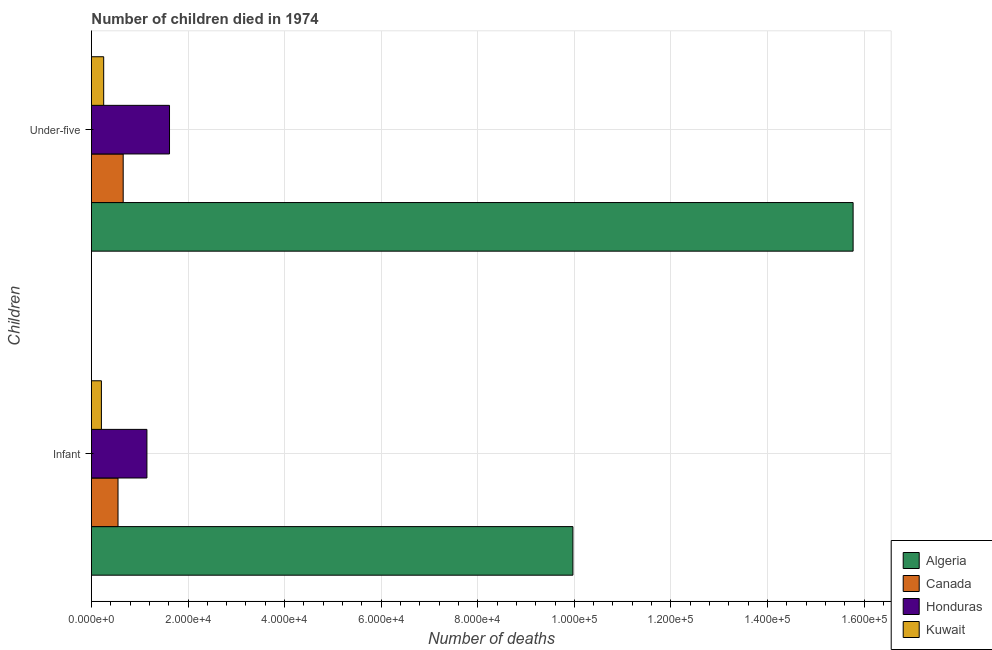How many groups of bars are there?
Offer a terse response. 2. Are the number of bars per tick equal to the number of legend labels?
Keep it short and to the point. Yes. Are the number of bars on each tick of the Y-axis equal?
Provide a succinct answer. Yes. How many bars are there on the 2nd tick from the top?
Keep it short and to the point. 4. How many bars are there on the 2nd tick from the bottom?
Offer a terse response. 4. What is the label of the 1st group of bars from the top?
Keep it short and to the point. Under-five. What is the number of under-five deaths in Algeria?
Give a very brief answer. 1.58e+05. Across all countries, what is the maximum number of under-five deaths?
Your response must be concise. 1.58e+05. Across all countries, what is the minimum number of under-five deaths?
Provide a short and direct response. 2539. In which country was the number of under-five deaths maximum?
Give a very brief answer. Algeria. In which country was the number of under-five deaths minimum?
Make the answer very short. Kuwait. What is the total number of under-five deaths in the graph?
Provide a short and direct response. 1.83e+05. What is the difference between the number of under-five deaths in Kuwait and that in Canada?
Keep it short and to the point. -4038. What is the difference between the number of under-five deaths in Honduras and the number of infant deaths in Canada?
Provide a succinct answer. 1.07e+04. What is the average number of infant deaths per country?
Keep it short and to the point. 2.97e+04. What is the difference between the number of under-five deaths and number of infant deaths in Algeria?
Provide a succinct answer. 5.80e+04. What is the ratio of the number of under-five deaths in Canada to that in Algeria?
Provide a succinct answer. 0.04. Is the number of under-five deaths in Kuwait less than that in Canada?
Offer a terse response. Yes. In how many countries, is the number of under-five deaths greater than the average number of under-five deaths taken over all countries?
Ensure brevity in your answer.  1. What does the 3rd bar from the top in Under-five represents?
Your answer should be very brief. Canada. What does the 1st bar from the bottom in Infant represents?
Make the answer very short. Algeria. Are all the bars in the graph horizontal?
Ensure brevity in your answer.  Yes. What is the difference between two consecutive major ticks on the X-axis?
Ensure brevity in your answer.  2.00e+04. Are the values on the major ticks of X-axis written in scientific E-notation?
Offer a very short reply. Yes. How many legend labels are there?
Offer a very short reply. 4. How are the legend labels stacked?
Ensure brevity in your answer.  Vertical. What is the title of the graph?
Provide a short and direct response. Number of children died in 1974. What is the label or title of the X-axis?
Offer a very short reply. Number of deaths. What is the label or title of the Y-axis?
Provide a short and direct response. Children. What is the Number of deaths of Algeria in Infant?
Your response must be concise. 9.97e+04. What is the Number of deaths in Canada in Infant?
Your response must be concise. 5505. What is the Number of deaths in Honduras in Infant?
Keep it short and to the point. 1.15e+04. What is the Number of deaths of Kuwait in Infant?
Your answer should be very brief. 2066. What is the Number of deaths of Algeria in Under-five?
Your answer should be compact. 1.58e+05. What is the Number of deaths in Canada in Under-five?
Offer a terse response. 6577. What is the Number of deaths in Honduras in Under-five?
Provide a short and direct response. 1.62e+04. What is the Number of deaths of Kuwait in Under-five?
Ensure brevity in your answer.  2539. Across all Children, what is the maximum Number of deaths of Algeria?
Your answer should be compact. 1.58e+05. Across all Children, what is the maximum Number of deaths of Canada?
Offer a terse response. 6577. Across all Children, what is the maximum Number of deaths in Honduras?
Ensure brevity in your answer.  1.62e+04. Across all Children, what is the maximum Number of deaths of Kuwait?
Your answer should be very brief. 2539. Across all Children, what is the minimum Number of deaths of Algeria?
Your answer should be very brief. 9.97e+04. Across all Children, what is the minimum Number of deaths of Canada?
Your answer should be very brief. 5505. Across all Children, what is the minimum Number of deaths of Honduras?
Keep it short and to the point. 1.15e+04. Across all Children, what is the minimum Number of deaths in Kuwait?
Provide a succinct answer. 2066. What is the total Number of deaths in Algeria in the graph?
Your response must be concise. 2.57e+05. What is the total Number of deaths in Canada in the graph?
Your answer should be very brief. 1.21e+04. What is the total Number of deaths of Honduras in the graph?
Offer a very short reply. 2.77e+04. What is the total Number of deaths of Kuwait in the graph?
Give a very brief answer. 4605. What is the difference between the Number of deaths of Algeria in Infant and that in Under-five?
Your response must be concise. -5.80e+04. What is the difference between the Number of deaths in Canada in Infant and that in Under-five?
Ensure brevity in your answer.  -1072. What is the difference between the Number of deaths in Honduras in Infant and that in Under-five?
Offer a very short reply. -4680. What is the difference between the Number of deaths in Kuwait in Infant and that in Under-five?
Make the answer very short. -473. What is the difference between the Number of deaths of Algeria in Infant and the Number of deaths of Canada in Under-five?
Your response must be concise. 9.31e+04. What is the difference between the Number of deaths of Algeria in Infant and the Number of deaths of Honduras in Under-five?
Give a very brief answer. 8.35e+04. What is the difference between the Number of deaths in Algeria in Infant and the Number of deaths in Kuwait in Under-five?
Provide a succinct answer. 9.72e+04. What is the difference between the Number of deaths of Canada in Infant and the Number of deaths of Honduras in Under-five?
Ensure brevity in your answer.  -1.07e+04. What is the difference between the Number of deaths in Canada in Infant and the Number of deaths in Kuwait in Under-five?
Offer a terse response. 2966. What is the difference between the Number of deaths of Honduras in Infant and the Number of deaths of Kuwait in Under-five?
Provide a short and direct response. 8952. What is the average Number of deaths in Algeria per Children?
Provide a short and direct response. 1.29e+05. What is the average Number of deaths in Canada per Children?
Offer a very short reply. 6041. What is the average Number of deaths of Honduras per Children?
Ensure brevity in your answer.  1.38e+04. What is the average Number of deaths of Kuwait per Children?
Offer a terse response. 2302.5. What is the difference between the Number of deaths in Algeria and Number of deaths in Canada in Infant?
Your answer should be compact. 9.42e+04. What is the difference between the Number of deaths in Algeria and Number of deaths in Honduras in Infant?
Offer a terse response. 8.82e+04. What is the difference between the Number of deaths of Algeria and Number of deaths of Kuwait in Infant?
Offer a terse response. 9.76e+04. What is the difference between the Number of deaths in Canada and Number of deaths in Honduras in Infant?
Keep it short and to the point. -5986. What is the difference between the Number of deaths in Canada and Number of deaths in Kuwait in Infant?
Your response must be concise. 3439. What is the difference between the Number of deaths in Honduras and Number of deaths in Kuwait in Infant?
Offer a very short reply. 9425. What is the difference between the Number of deaths in Algeria and Number of deaths in Canada in Under-five?
Offer a terse response. 1.51e+05. What is the difference between the Number of deaths in Algeria and Number of deaths in Honduras in Under-five?
Make the answer very short. 1.42e+05. What is the difference between the Number of deaths of Algeria and Number of deaths of Kuwait in Under-five?
Make the answer very short. 1.55e+05. What is the difference between the Number of deaths in Canada and Number of deaths in Honduras in Under-five?
Ensure brevity in your answer.  -9594. What is the difference between the Number of deaths in Canada and Number of deaths in Kuwait in Under-five?
Keep it short and to the point. 4038. What is the difference between the Number of deaths in Honduras and Number of deaths in Kuwait in Under-five?
Ensure brevity in your answer.  1.36e+04. What is the ratio of the Number of deaths of Algeria in Infant to that in Under-five?
Give a very brief answer. 0.63. What is the ratio of the Number of deaths of Canada in Infant to that in Under-five?
Ensure brevity in your answer.  0.84. What is the ratio of the Number of deaths in Honduras in Infant to that in Under-five?
Keep it short and to the point. 0.71. What is the ratio of the Number of deaths in Kuwait in Infant to that in Under-five?
Your answer should be compact. 0.81. What is the difference between the highest and the second highest Number of deaths of Algeria?
Your answer should be very brief. 5.80e+04. What is the difference between the highest and the second highest Number of deaths in Canada?
Keep it short and to the point. 1072. What is the difference between the highest and the second highest Number of deaths of Honduras?
Make the answer very short. 4680. What is the difference between the highest and the second highest Number of deaths of Kuwait?
Your answer should be very brief. 473. What is the difference between the highest and the lowest Number of deaths in Algeria?
Make the answer very short. 5.80e+04. What is the difference between the highest and the lowest Number of deaths in Canada?
Ensure brevity in your answer.  1072. What is the difference between the highest and the lowest Number of deaths in Honduras?
Offer a very short reply. 4680. What is the difference between the highest and the lowest Number of deaths of Kuwait?
Offer a very short reply. 473. 